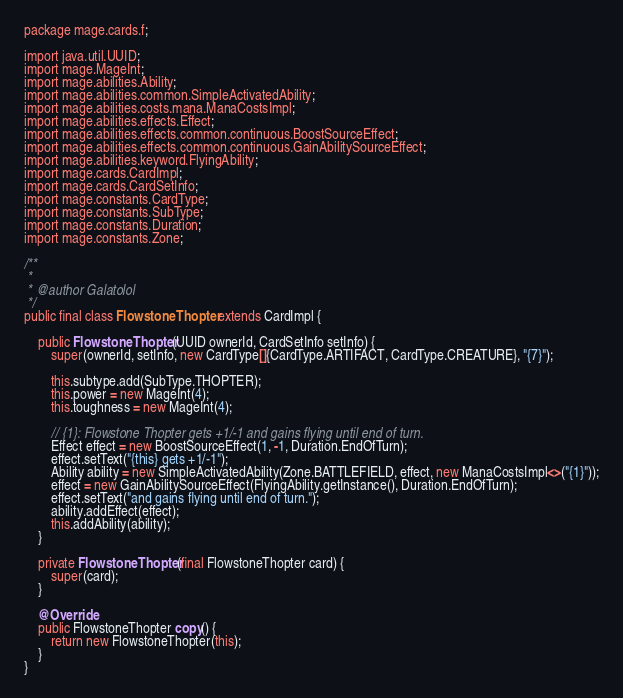Convert code to text. <code><loc_0><loc_0><loc_500><loc_500><_Java_>
package mage.cards.f;

import java.util.UUID;
import mage.MageInt;
import mage.abilities.Ability;
import mage.abilities.common.SimpleActivatedAbility;
import mage.abilities.costs.mana.ManaCostsImpl;
import mage.abilities.effects.Effect;
import mage.abilities.effects.common.continuous.BoostSourceEffect;
import mage.abilities.effects.common.continuous.GainAbilitySourceEffect;
import mage.abilities.keyword.FlyingAbility;
import mage.cards.CardImpl;
import mage.cards.CardSetInfo;
import mage.constants.CardType;
import mage.constants.SubType;
import mage.constants.Duration;
import mage.constants.Zone;

/**
 *
 * @author Galatolol
 */
public final class FlowstoneThopter extends CardImpl {

    public FlowstoneThopter(UUID ownerId, CardSetInfo setInfo) {
        super(ownerId, setInfo, new CardType[]{CardType.ARTIFACT, CardType.CREATURE}, "{7}");
        
        this.subtype.add(SubType.THOPTER);
        this.power = new MageInt(4);
        this.toughness = new MageInt(4);

        // {1}: Flowstone Thopter gets +1/-1 and gains flying until end of turn.
        Effect effect = new BoostSourceEffect(1, -1, Duration.EndOfTurn);
        effect.setText("{this} gets +1/-1");
        Ability ability = new SimpleActivatedAbility(Zone.BATTLEFIELD, effect, new ManaCostsImpl<>("{1}"));
        effect = new GainAbilitySourceEffect(FlyingAbility.getInstance(), Duration.EndOfTurn);
        effect.setText("and gains flying until end of turn.");
        ability.addEffect(effect);
        this.addAbility(ability);
    }

    private FlowstoneThopter(final FlowstoneThopter card) {
        super(card);
    }

    @Override
    public FlowstoneThopter copy() {
        return new FlowstoneThopter(this);
    }
}
</code> 